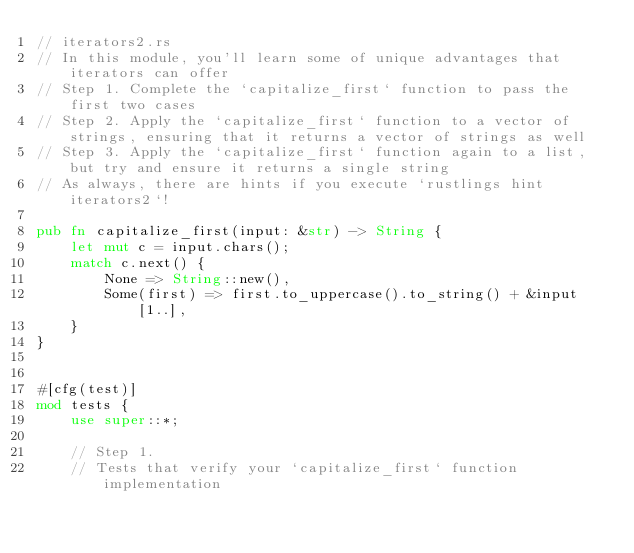<code> <loc_0><loc_0><loc_500><loc_500><_Rust_>// iterators2.rs
// In this module, you'll learn some of unique advantages that iterators can offer
// Step 1. Complete the `capitalize_first` function to pass the first two cases
// Step 2. Apply the `capitalize_first` function to a vector of strings, ensuring that it returns a vector of strings as well
// Step 3. Apply the `capitalize_first` function again to a list, but try and ensure it returns a single string
// As always, there are hints if you execute `rustlings hint iterators2`!

pub fn capitalize_first(input: &str) -> String {
    let mut c = input.chars();
    match c.next() {
        None => String::new(),
        Some(first) => first.to_uppercase().to_string() + &input[1..],
    }
}


#[cfg(test)]
mod tests {
    use super::*;

    // Step 1.
    // Tests that verify your `capitalize_first` function implementation</code> 